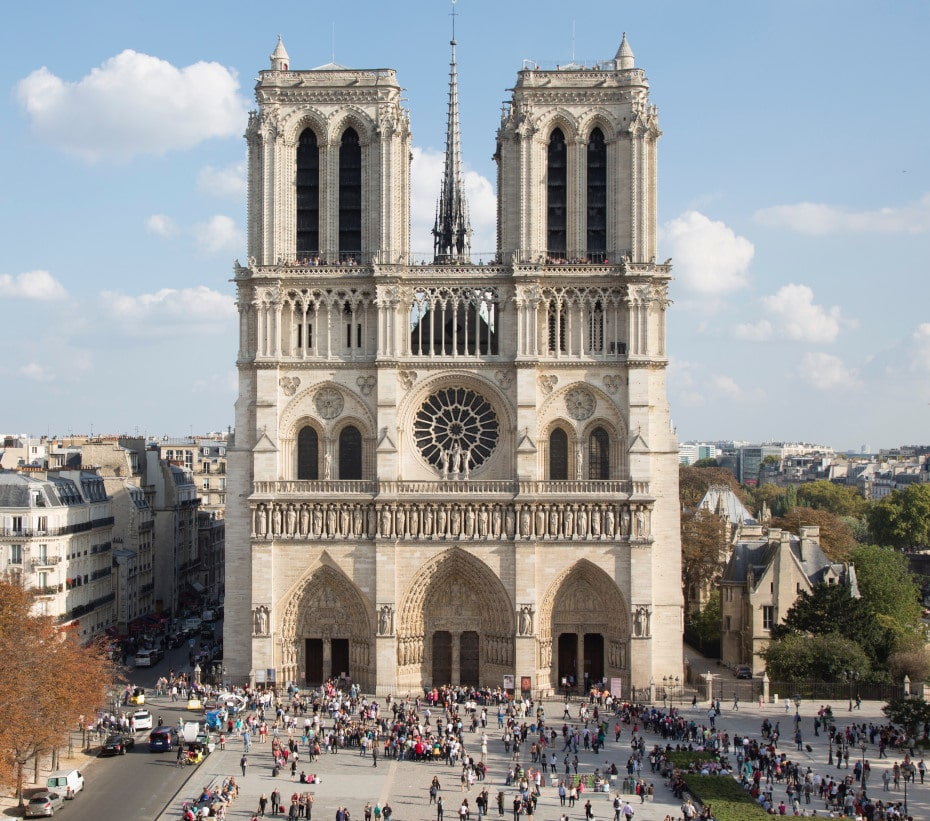Imagine the cathedral in an alternative reality where it is the focal point of a futuristic city. Describe it. In an alternative reality, the Notre Dame Cathedral stands as a magnificent relic amidst a bustling futuristic city, where soaring glass skyscrapers and advanced technology dominate the skyline. The façade of the cathedral has been preserved with advanced nano-materials, giving its ancient stone an almost timeless glow. Hovering drones and flying vehicles navigate the air, their neon lights casting a surreal glow upon the gothic spires and the rose window, which now integrates augmented reality displays that convey historical information and digital art. The square in front is now an expansive, levitating plaza with a transparent surface that offers views of an underground city below. Despite the stark contrast with its surroundings, the cathedral remains a revered sanctuary where people seek peace and reflection amidst the hustle and bustle of a high-tech society. How might the architectural techniques used in Notre Dame influence the design of modern buildings in this futuristic city? The architectural ingenuity of Notre Dame Cathedral could profoundly influence the design of modern buildings in a futuristic city. Elements such as the use of verticality, the intricate stonework, and the integration of natural light through large stained glass windows could inspire a blend of gothic aesthetics with high-tech innovation. Architects might incorporate soaring structures that mimic spires, utilizing lightweight, sustainable materials with the strength of modern composites. Advanced 3D printing technology could replicate the intricate stone carvings to create facades that tell stories, blending historical artistry with contemporary motifs. The concept of large, open interiors infused with natural light could lead to innovative space designs that merge functionality with serene beauty, echoing the timeless elegance of gothic cathedrals. Can you think of a fictional story set in this futuristic city with the cathedral as a central element? In the heart of a futuristic city where mythology and modernity intertwine, stands the revered Notre Dame Cathedral, a sanctuary amidst the neon-lit shadows. In this tale, an orphan named Elara, gifted with the rare ability to see glimpses of the past and future, discovers a hidden message in the augmented reality displays of the cathedral's rose window. This message, left by an ancient order of guardians, speaks of an impending catastrophe that could unravel the city's fabric. As she deciphers the cryptic message, Elara is drawn into a secret world beneath the levitating plaza, where the ancient and technologically advanced coexist. With the help of a renegade scientist and a group of rebels, she embarks on a quest to unlock the cathedral's long-lost secrets to prevent the catastrophe. Along the way, she discovers her own destiny is intricately linked with the cathedral's ancient past and the city’s future, culminating in a climactic battle that could save or doom this futuristic metropolis. 